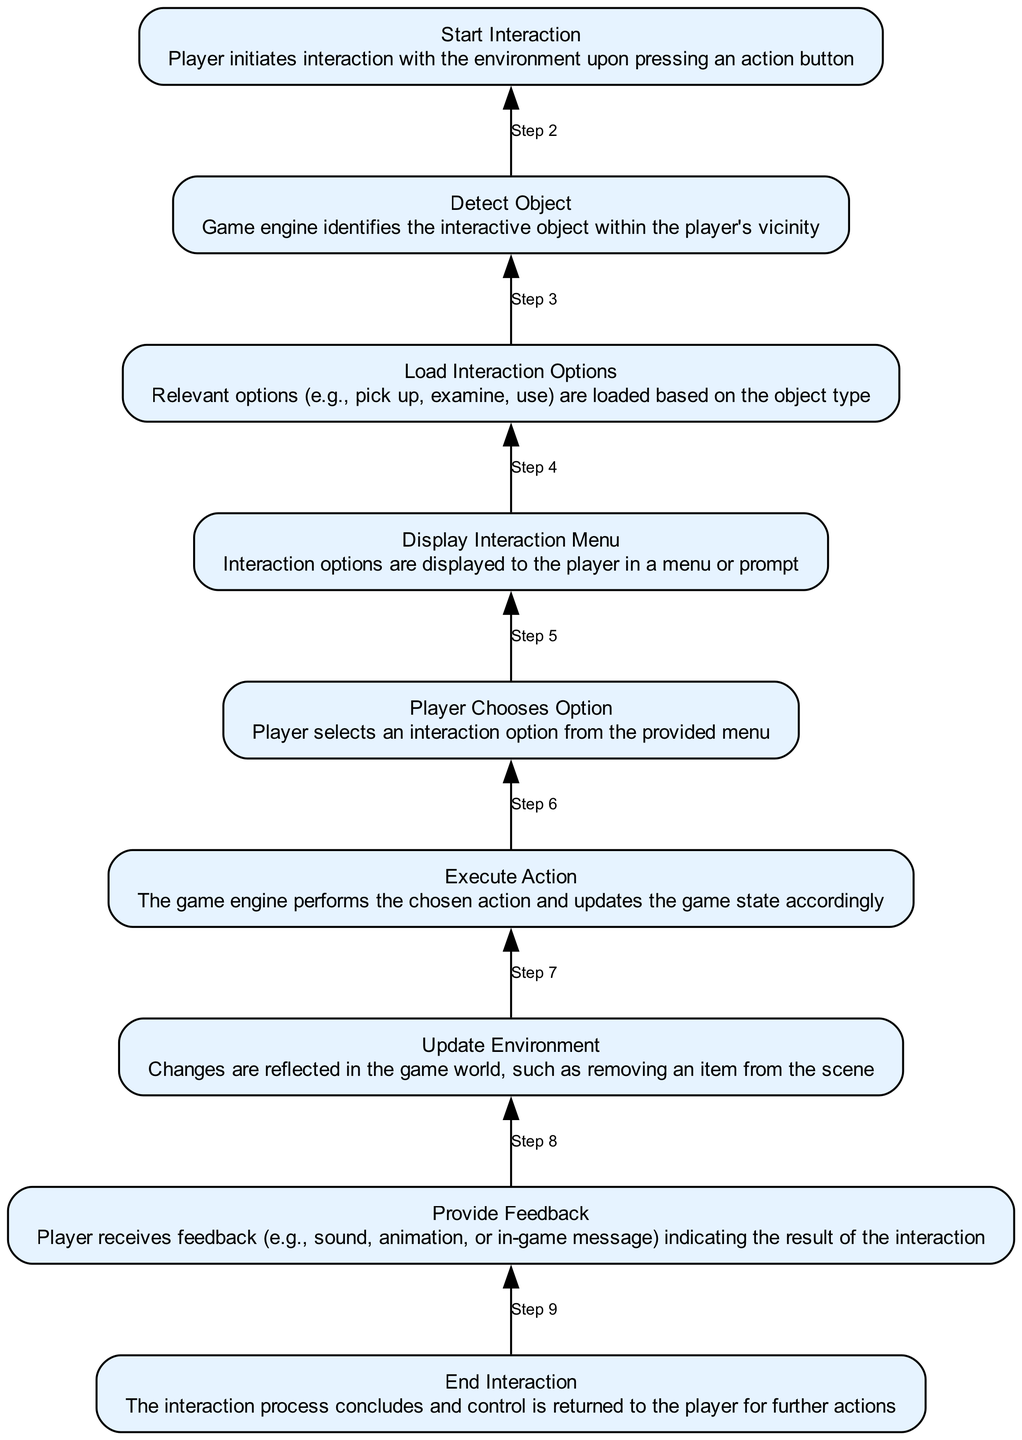What is the first step in the interaction? The first step is labeled as "Start Interaction." It is the bottom-most node in the flowchart and signifies where the process begins.
Answer: Start Interaction How many nodes are present in the diagram? Counting all the labeled steps from "Start Interaction" to "End Interaction," there are a total of nine nodes.
Answer: Nine What is displayed after "Load Interaction Options"? After "Load Interaction Options," the next step is "Display Interaction Menu," indicating that the game presents the player with options.
Answer: Display Interaction Menu What action follows "Player Chooses Option"? The action that follows "Player Chooses Option" is "Execute Action," meaning the chosen interaction is performed in the game.
Answer: Execute Action What feedback is given to the player? The feedback provided to the player is outlined in the step "Provide Feedback," indicating how the game communicates the outcome of the interaction.
Answer: Provide Feedback What is the last step in the interaction process? The last step in the process is labeled "End Interaction," which signifies the conclusion of the interaction sequence.
Answer: End Interaction What is the relationship between "Detect Object" and "Load Interaction Options"? "Load Interaction Options" is dependent on "Detect Object" being successfully completed first; therefore, they are sequential steps in the interaction process.
Answer: Sequential steps How does the interaction start? The interaction starts when the player presses an action button, as described in the node "Start Interaction."
Answer: Player presses an action button What type of feedback can players receive after an action? Players can receive feedback such as sound, animation, or in-game message as indicated in the "Provide Feedback" node.
Answer: Sound, animation, in-game message 